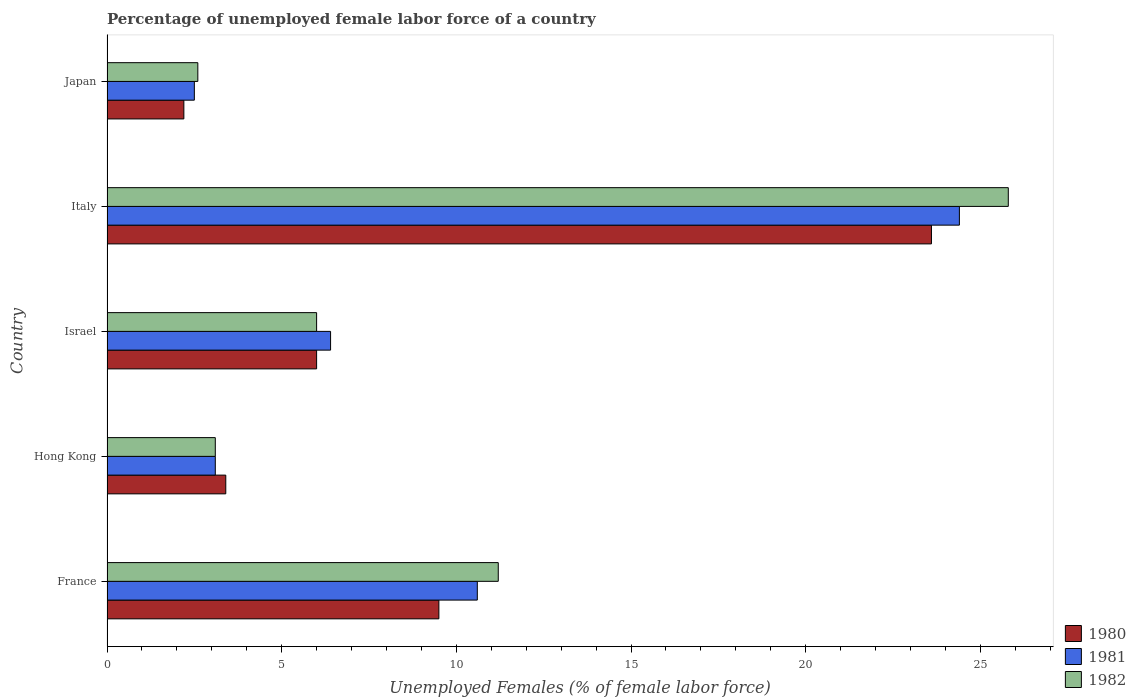How many different coloured bars are there?
Provide a short and direct response. 3. How many groups of bars are there?
Your response must be concise. 5. How many bars are there on the 3rd tick from the bottom?
Provide a succinct answer. 3. What is the label of the 5th group of bars from the top?
Ensure brevity in your answer.  France. In how many cases, is the number of bars for a given country not equal to the number of legend labels?
Keep it short and to the point. 0. Across all countries, what is the maximum percentage of unemployed female labor force in 1981?
Provide a succinct answer. 24.4. Across all countries, what is the minimum percentage of unemployed female labor force in 1980?
Make the answer very short. 2.2. In which country was the percentage of unemployed female labor force in 1980 minimum?
Provide a succinct answer. Japan. What is the total percentage of unemployed female labor force in 1981 in the graph?
Give a very brief answer. 47. What is the difference between the percentage of unemployed female labor force in 1982 in Italy and that in Japan?
Provide a succinct answer. 23.2. What is the difference between the percentage of unemployed female labor force in 1981 in Israel and the percentage of unemployed female labor force in 1982 in Japan?
Provide a succinct answer. 3.8. What is the average percentage of unemployed female labor force in 1981 per country?
Make the answer very short. 9.4. What is the difference between the percentage of unemployed female labor force in 1982 and percentage of unemployed female labor force in 1981 in Hong Kong?
Make the answer very short. 0. What is the ratio of the percentage of unemployed female labor force in 1981 in France to that in Hong Kong?
Keep it short and to the point. 3.42. Is the difference between the percentage of unemployed female labor force in 1982 in France and Japan greater than the difference between the percentage of unemployed female labor force in 1981 in France and Japan?
Provide a succinct answer. Yes. What is the difference between the highest and the second highest percentage of unemployed female labor force in 1980?
Ensure brevity in your answer.  14.1. What is the difference between the highest and the lowest percentage of unemployed female labor force in 1981?
Give a very brief answer. 21.9. In how many countries, is the percentage of unemployed female labor force in 1982 greater than the average percentage of unemployed female labor force in 1982 taken over all countries?
Provide a succinct answer. 2. Is the sum of the percentage of unemployed female labor force in 1980 in France and Japan greater than the maximum percentage of unemployed female labor force in 1981 across all countries?
Offer a very short reply. No. What does the 3rd bar from the bottom in Italy represents?
Your response must be concise. 1982. Is it the case that in every country, the sum of the percentage of unemployed female labor force in 1981 and percentage of unemployed female labor force in 1980 is greater than the percentage of unemployed female labor force in 1982?
Offer a very short reply. Yes. Are all the bars in the graph horizontal?
Offer a very short reply. Yes. How many countries are there in the graph?
Keep it short and to the point. 5. What is the difference between two consecutive major ticks on the X-axis?
Your response must be concise. 5. Are the values on the major ticks of X-axis written in scientific E-notation?
Make the answer very short. No. Where does the legend appear in the graph?
Provide a succinct answer. Bottom right. How are the legend labels stacked?
Give a very brief answer. Vertical. What is the title of the graph?
Offer a terse response. Percentage of unemployed female labor force of a country. Does "2002" appear as one of the legend labels in the graph?
Your answer should be very brief. No. What is the label or title of the X-axis?
Your answer should be compact. Unemployed Females (% of female labor force). What is the label or title of the Y-axis?
Your answer should be compact. Country. What is the Unemployed Females (% of female labor force) of 1981 in France?
Your answer should be compact. 10.6. What is the Unemployed Females (% of female labor force) in 1982 in France?
Your answer should be compact. 11.2. What is the Unemployed Females (% of female labor force) in 1980 in Hong Kong?
Keep it short and to the point. 3.4. What is the Unemployed Females (% of female labor force) of 1981 in Hong Kong?
Make the answer very short. 3.1. What is the Unemployed Females (% of female labor force) of 1982 in Hong Kong?
Keep it short and to the point. 3.1. What is the Unemployed Females (% of female labor force) in 1981 in Israel?
Provide a short and direct response. 6.4. What is the Unemployed Females (% of female labor force) in 1982 in Israel?
Keep it short and to the point. 6. What is the Unemployed Females (% of female labor force) of 1980 in Italy?
Give a very brief answer. 23.6. What is the Unemployed Females (% of female labor force) of 1981 in Italy?
Provide a succinct answer. 24.4. What is the Unemployed Females (% of female labor force) in 1982 in Italy?
Keep it short and to the point. 25.8. What is the Unemployed Females (% of female labor force) of 1980 in Japan?
Provide a short and direct response. 2.2. What is the Unemployed Females (% of female labor force) of 1982 in Japan?
Keep it short and to the point. 2.6. Across all countries, what is the maximum Unemployed Females (% of female labor force) of 1980?
Make the answer very short. 23.6. Across all countries, what is the maximum Unemployed Females (% of female labor force) of 1981?
Your answer should be compact. 24.4. Across all countries, what is the maximum Unemployed Females (% of female labor force) of 1982?
Provide a succinct answer. 25.8. Across all countries, what is the minimum Unemployed Females (% of female labor force) of 1980?
Keep it short and to the point. 2.2. Across all countries, what is the minimum Unemployed Females (% of female labor force) in 1981?
Your answer should be compact. 2.5. Across all countries, what is the minimum Unemployed Females (% of female labor force) of 1982?
Your answer should be very brief. 2.6. What is the total Unemployed Females (% of female labor force) of 1980 in the graph?
Provide a succinct answer. 44.7. What is the total Unemployed Females (% of female labor force) of 1981 in the graph?
Make the answer very short. 47. What is the total Unemployed Females (% of female labor force) of 1982 in the graph?
Keep it short and to the point. 48.7. What is the difference between the Unemployed Females (% of female labor force) of 1981 in France and that in Hong Kong?
Ensure brevity in your answer.  7.5. What is the difference between the Unemployed Females (% of female labor force) in 1981 in France and that in Israel?
Provide a short and direct response. 4.2. What is the difference between the Unemployed Females (% of female labor force) in 1982 in France and that in Israel?
Ensure brevity in your answer.  5.2. What is the difference between the Unemployed Females (% of female labor force) in 1980 in France and that in Italy?
Make the answer very short. -14.1. What is the difference between the Unemployed Females (% of female labor force) in 1982 in France and that in Italy?
Provide a short and direct response. -14.6. What is the difference between the Unemployed Females (% of female labor force) of 1980 in France and that in Japan?
Your answer should be compact. 7.3. What is the difference between the Unemployed Females (% of female labor force) in 1981 in France and that in Japan?
Provide a succinct answer. 8.1. What is the difference between the Unemployed Females (% of female labor force) of 1982 in France and that in Japan?
Offer a terse response. 8.6. What is the difference between the Unemployed Females (% of female labor force) of 1980 in Hong Kong and that in Israel?
Ensure brevity in your answer.  -2.6. What is the difference between the Unemployed Females (% of female labor force) in 1980 in Hong Kong and that in Italy?
Ensure brevity in your answer.  -20.2. What is the difference between the Unemployed Females (% of female labor force) in 1981 in Hong Kong and that in Italy?
Offer a terse response. -21.3. What is the difference between the Unemployed Females (% of female labor force) in 1982 in Hong Kong and that in Italy?
Make the answer very short. -22.7. What is the difference between the Unemployed Females (% of female labor force) in 1982 in Hong Kong and that in Japan?
Your answer should be very brief. 0.5. What is the difference between the Unemployed Females (% of female labor force) of 1980 in Israel and that in Italy?
Ensure brevity in your answer.  -17.6. What is the difference between the Unemployed Females (% of female labor force) in 1982 in Israel and that in Italy?
Your response must be concise. -19.8. What is the difference between the Unemployed Females (% of female labor force) in 1980 in Italy and that in Japan?
Your answer should be very brief. 21.4. What is the difference between the Unemployed Females (% of female labor force) in 1981 in Italy and that in Japan?
Ensure brevity in your answer.  21.9. What is the difference between the Unemployed Females (% of female labor force) in 1982 in Italy and that in Japan?
Offer a terse response. 23.2. What is the difference between the Unemployed Females (% of female labor force) in 1980 in France and the Unemployed Females (% of female labor force) in 1981 in Hong Kong?
Make the answer very short. 6.4. What is the difference between the Unemployed Females (% of female labor force) of 1980 in France and the Unemployed Females (% of female labor force) of 1982 in Hong Kong?
Offer a very short reply. 6.4. What is the difference between the Unemployed Females (% of female labor force) of 1980 in France and the Unemployed Females (% of female labor force) of 1982 in Israel?
Give a very brief answer. 3.5. What is the difference between the Unemployed Females (% of female labor force) of 1981 in France and the Unemployed Females (% of female labor force) of 1982 in Israel?
Offer a terse response. 4.6. What is the difference between the Unemployed Females (% of female labor force) of 1980 in France and the Unemployed Females (% of female labor force) of 1981 in Italy?
Provide a succinct answer. -14.9. What is the difference between the Unemployed Females (% of female labor force) of 1980 in France and the Unemployed Females (% of female labor force) of 1982 in Italy?
Offer a terse response. -16.3. What is the difference between the Unemployed Females (% of female labor force) of 1981 in France and the Unemployed Females (% of female labor force) of 1982 in Italy?
Make the answer very short. -15.2. What is the difference between the Unemployed Females (% of female labor force) in 1980 in France and the Unemployed Females (% of female labor force) in 1981 in Japan?
Provide a short and direct response. 7. What is the difference between the Unemployed Females (% of female labor force) in 1980 in France and the Unemployed Females (% of female labor force) in 1982 in Japan?
Offer a very short reply. 6.9. What is the difference between the Unemployed Females (% of female labor force) in 1981 in France and the Unemployed Females (% of female labor force) in 1982 in Japan?
Your response must be concise. 8. What is the difference between the Unemployed Females (% of female labor force) in 1980 in Hong Kong and the Unemployed Females (% of female labor force) in 1981 in Israel?
Your answer should be very brief. -3. What is the difference between the Unemployed Females (% of female labor force) of 1980 in Hong Kong and the Unemployed Females (% of female labor force) of 1982 in Israel?
Offer a terse response. -2.6. What is the difference between the Unemployed Females (% of female labor force) in 1981 in Hong Kong and the Unemployed Females (% of female labor force) in 1982 in Israel?
Offer a very short reply. -2.9. What is the difference between the Unemployed Females (% of female labor force) in 1980 in Hong Kong and the Unemployed Females (% of female labor force) in 1982 in Italy?
Ensure brevity in your answer.  -22.4. What is the difference between the Unemployed Females (% of female labor force) of 1981 in Hong Kong and the Unemployed Females (% of female labor force) of 1982 in Italy?
Offer a very short reply. -22.7. What is the difference between the Unemployed Females (% of female labor force) in 1980 in Hong Kong and the Unemployed Females (% of female labor force) in 1981 in Japan?
Give a very brief answer. 0.9. What is the difference between the Unemployed Females (% of female labor force) of 1981 in Hong Kong and the Unemployed Females (% of female labor force) of 1982 in Japan?
Provide a short and direct response. 0.5. What is the difference between the Unemployed Females (% of female labor force) of 1980 in Israel and the Unemployed Females (% of female labor force) of 1981 in Italy?
Make the answer very short. -18.4. What is the difference between the Unemployed Females (% of female labor force) of 1980 in Israel and the Unemployed Females (% of female labor force) of 1982 in Italy?
Your response must be concise. -19.8. What is the difference between the Unemployed Females (% of female labor force) in 1981 in Israel and the Unemployed Females (% of female labor force) in 1982 in Italy?
Keep it short and to the point. -19.4. What is the difference between the Unemployed Females (% of female labor force) in 1981 in Israel and the Unemployed Females (% of female labor force) in 1982 in Japan?
Provide a short and direct response. 3.8. What is the difference between the Unemployed Females (% of female labor force) in 1980 in Italy and the Unemployed Females (% of female labor force) in 1981 in Japan?
Your response must be concise. 21.1. What is the difference between the Unemployed Females (% of female labor force) of 1980 in Italy and the Unemployed Females (% of female labor force) of 1982 in Japan?
Your answer should be compact. 21. What is the difference between the Unemployed Females (% of female labor force) of 1981 in Italy and the Unemployed Females (% of female labor force) of 1982 in Japan?
Provide a succinct answer. 21.8. What is the average Unemployed Females (% of female labor force) of 1980 per country?
Offer a very short reply. 8.94. What is the average Unemployed Females (% of female labor force) of 1982 per country?
Your answer should be very brief. 9.74. What is the difference between the Unemployed Females (% of female labor force) in 1980 and Unemployed Females (% of female labor force) in 1982 in France?
Provide a succinct answer. -1.7. What is the difference between the Unemployed Females (% of female labor force) in 1981 and Unemployed Females (% of female labor force) in 1982 in France?
Provide a succinct answer. -0.6. What is the difference between the Unemployed Females (% of female labor force) of 1980 and Unemployed Females (% of female labor force) of 1981 in Hong Kong?
Your answer should be compact. 0.3. What is the difference between the Unemployed Females (% of female labor force) of 1980 and Unemployed Females (% of female labor force) of 1982 in Hong Kong?
Your response must be concise. 0.3. What is the difference between the Unemployed Females (% of female labor force) in 1981 and Unemployed Females (% of female labor force) in 1982 in Hong Kong?
Keep it short and to the point. 0. What is the difference between the Unemployed Females (% of female labor force) in 1980 and Unemployed Females (% of female labor force) in 1982 in Israel?
Provide a succinct answer. 0. What is the difference between the Unemployed Females (% of female labor force) in 1980 and Unemployed Females (% of female labor force) in 1982 in Japan?
Ensure brevity in your answer.  -0.4. What is the difference between the Unemployed Females (% of female labor force) in 1981 and Unemployed Females (% of female labor force) in 1982 in Japan?
Your response must be concise. -0.1. What is the ratio of the Unemployed Females (% of female labor force) of 1980 in France to that in Hong Kong?
Your response must be concise. 2.79. What is the ratio of the Unemployed Females (% of female labor force) in 1981 in France to that in Hong Kong?
Your answer should be compact. 3.42. What is the ratio of the Unemployed Females (% of female labor force) in 1982 in France to that in Hong Kong?
Offer a terse response. 3.61. What is the ratio of the Unemployed Females (% of female labor force) in 1980 in France to that in Israel?
Your answer should be very brief. 1.58. What is the ratio of the Unemployed Females (% of female labor force) of 1981 in France to that in Israel?
Provide a short and direct response. 1.66. What is the ratio of the Unemployed Females (% of female labor force) of 1982 in France to that in Israel?
Keep it short and to the point. 1.87. What is the ratio of the Unemployed Females (% of female labor force) in 1980 in France to that in Italy?
Your answer should be compact. 0.4. What is the ratio of the Unemployed Females (% of female labor force) of 1981 in France to that in Italy?
Ensure brevity in your answer.  0.43. What is the ratio of the Unemployed Females (% of female labor force) in 1982 in France to that in Italy?
Make the answer very short. 0.43. What is the ratio of the Unemployed Females (% of female labor force) in 1980 in France to that in Japan?
Make the answer very short. 4.32. What is the ratio of the Unemployed Females (% of female labor force) of 1981 in France to that in Japan?
Offer a very short reply. 4.24. What is the ratio of the Unemployed Females (% of female labor force) of 1982 in France to that in Japan?
Offer a terse response. 4.31. What is the ratio of the Unemployed Females (% of female labor force) in 1980 in Hong Kong to that in Israel?
Keep it short and to the point. 0.57. What is the ratio of the Unemployed Females (% of female labor force) of 1981 in Hong Kong to that in Israel?
Offer a very short reply. 0.48. What is the ratio of the Unemployed Females (% of female labor force) in 1982 in Hong Kong to that in Israel?
Make the answer very short. 0.52. What is the ratio of the Unemployed Females (% of female labor force) in 1980 in Hong Kong to that in Italy?
Your answer should be very brief. 0.14. What is the ratio of the Unemployed Females (% of female labor force) in 1981 in Hong Kong to that in Italy?
Provide a short and direct response. 0.13. What is the ratio of the Unemployed Females (% of female labor force) of 1982 in Hong Kong to that in Italy?
Provide a succinct answer. 0.12. What is the ratio of the Unemployed Females (% of female labor force) of 1980 in Hong Kong to that in Japan?
Keep it short and to the point. 1.55. What is the ratio of the Unemployed Females (% of female labor force) in 1981 in Hong Kong to that in Japan?
Your response must be concise. 1.24. What is the ratio of the Unemployed Females (% of female labor force) of 1982 in Hong Kong to that in Japan?
Make the answer very short. 1.19. What is the ratio of the Unemployed Females (% of female labor force) of 1980 in Israel to that in Italy?
Offer a terse response. 0.25. What is the ratio of the Unemployed Females (% of female labor force) of 1981 in Israel to that in Italy?
Provide a short and direct response. 0.26. What is the ratio of the Unemployed Females (% of female labor force) of 1982 in Israel to that in Italy?
Your answer should be very brief. 0.23. What is the ratio of the Unemployed Females (% of female labor force) in 1980 in Israel to that in Japan?
Provide a succinct answer. 2.73. What is the ratio of the Unemployed Females (% of female labor force) in 1981 in Israel to that in Japan?
Provide a short and direct response. 2.56. What is the ratio of the Unemployed Females (% of female labor force) in 1982 in Israel to that in Japan?
Your response must be concise. 2.31. What is the ratio of the Unemployed Females (% of female labor force) in 1980 in Italy to that in Japan?
Provide a short and direct response. 10.73. What is the ratio of the Unemployed Females (% of female labor force) of 1981 in Italy to that in Japan?
Offer a very short reply. 9.76. What is the ratio of the Unemployed Females (% of female labor force) in 1982 in Italy to that in Japan?
Offer a very short reply. 9.92. What is the difference between the highest and the lowest Unemployed Females (% of female labor force) in 1980?
Make the answer very short. 21.4. What is the difference between the highest and the lowest Unemployed Females (% of female labor force) in 1981?
Provide a succinct answer. 21.9. What is the difference between the highest and the lowest Unemployed Females (% of female labor force) of 1982?
Offer a terse response. 23.2. 